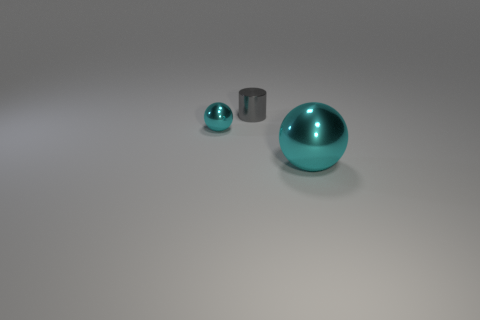Add 3 big yellow matte balls. How many objects exist? 6 Subtract all cylinders. How many objects are left? 2 Add 3 cyan spheres. How many cyan spheres exist? 5 Subtract 0 yellow cylinders. How many objects are left? 3 Subtract all large metallic spheres. Subtract all small cyan objects. How many objects are left? 1 Add 1 cyan things. How many cyan things are left? 3 